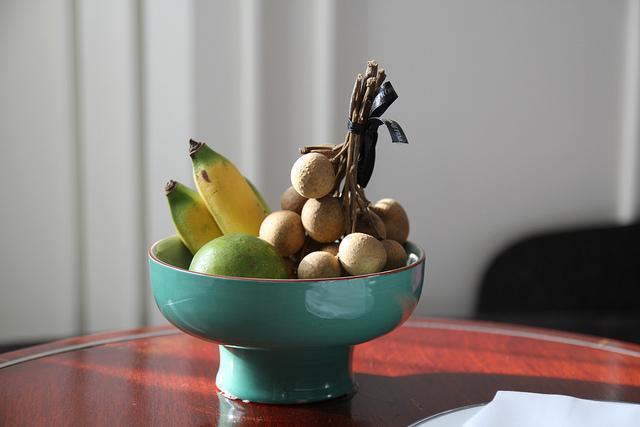How many different fruits are in the bowl?
Give a very brief answer. 3. 